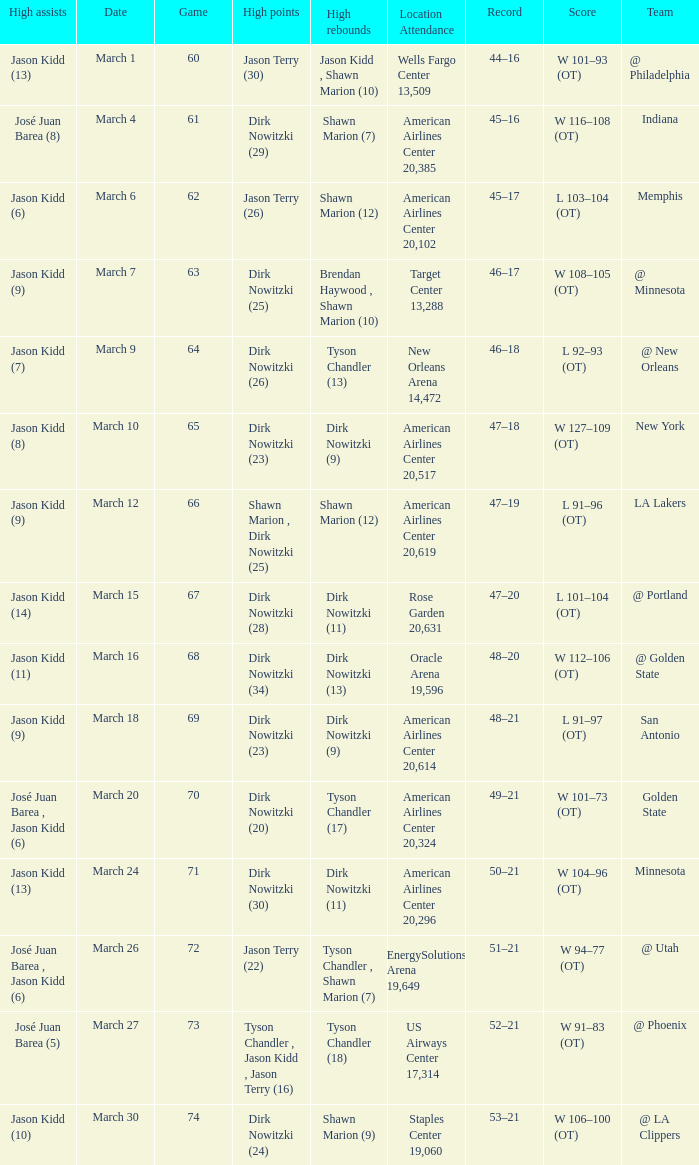Name the score for  josé juan barea (8) W 116–108 (OT). 